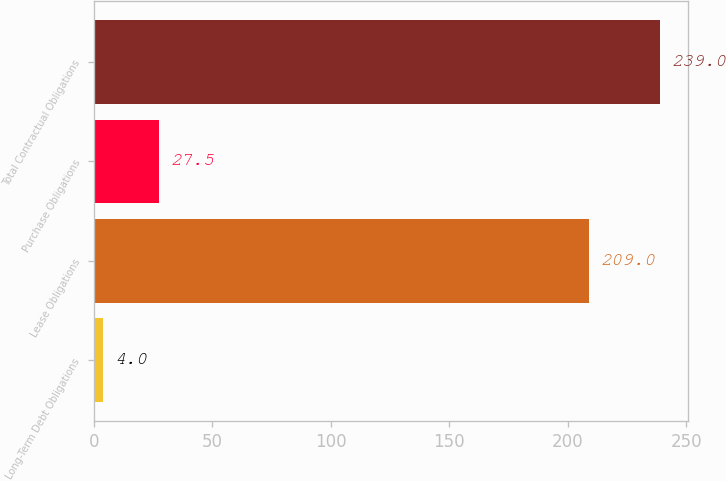Convert chart. <chart><loc_0><loc_0><loc_500><loc_500><bar_chart><fcel>Long-Term Debt Obligations<fcel>Lease Obligations<fcel>Purchase Obligations<fcel>Total Contractual Obligations<nl><fcel>4<fcel>209<fcel>27.5<fcel>239<nl></chart> 